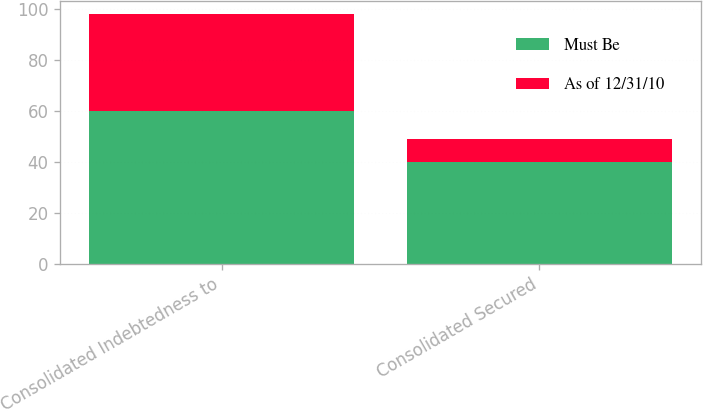<chart> <loc_0><loc_0><loc_500><loc_500><stacked_bar_chart><ecel><fcel>Consolidated Indebtedness to<fcel>Consolidated Secured<nl><fcel>Must Be<fcel>60<fcel>40<nl><fcel>As of 12/31/10<fcel>38<fcel>9<nl></chart> 